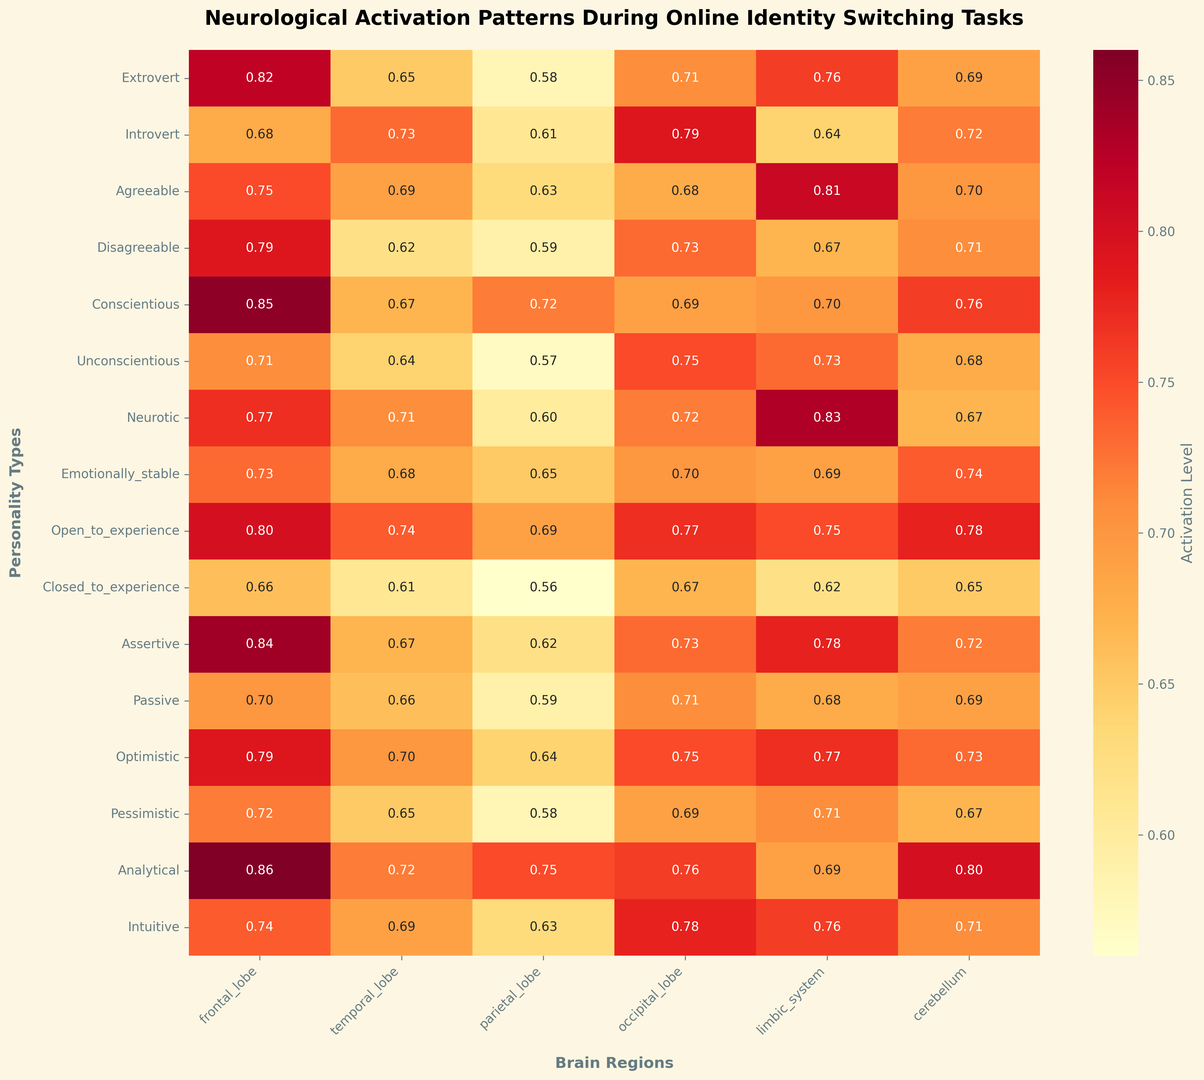Which personality type shows the highest activation level in the frontal lobe? To determine the highest activation level in the frontal lobe, look at the values under the “frontal_lobe” column. The highest value corresponds to the “Analytical” personality type with a value of 0.86.
Answer: Analytical Which brain region shows the most activation for the "Open_to_experience" personality type? For the "Open_to_experience" row, compare the values across all brain regions. The highest value is 0.78 in the "cerebellum" column.
Answer: Cerebellum What is the average activation level in the parietal lobe across all personality types? Sum the activation levels in the parietal lobe for all personality types and divide by the number of personality types. (0.58 + 0.61 + 0.63 + 0.59 + 0.72 + 0.57 + 0.60 + 0.65 + 0.69 + 0.56 + 0.62 + 0.59 + 0.64 + 0.58 + 0.75 + 0.63) / 16 = 10.21 / 16 = 0.64
Answer: 0.64 Is the activation level in the limbic system of “Neurotic” greater than the same region in “Agreeable”? Compare the activation level in the limbic system, which is 0.83 for "Neurotic" and 0.81 for "Agreeable." Since 0.83 is greater than 0.81, the activation is higher in "Neurotic".
Answer: Yes Which personality type has the least activation in the occipital lobe? In the “occipital_lobe” column, the smallest value is 0.67, corresponding to the “Closed_to_experience” personality type.
Answer: Closed_to_experience By how much does the activation level in the temporal lobe of “Extrovert” exceed that of “Disagreeable”? The activation level in the temporal lobe for "Extrovert" is 0.65, and for "Disagreeable," it is 0.62. The difference is 0.65 - 0.62 = 0.03.
Answer: 0.03 What is the sum of activation levels in the limbic system for “Conscientious” and “Optimistic” personality types? Add the activation levels in the limbic system for "Conscientious" (0.70) and "Optimistic" (0.77). The sum is 0.70 + 0.77 = 1.47.
Answer: 1.47 Which brain region shows the least variation in activation levels across all personality types? To identify this, notice the uniformity of the shading intensity across rows for each brain region. The cerebellum has consistent and closely clustered values compared to other regions, indicating the least variation.
Answer: Cerebellum 